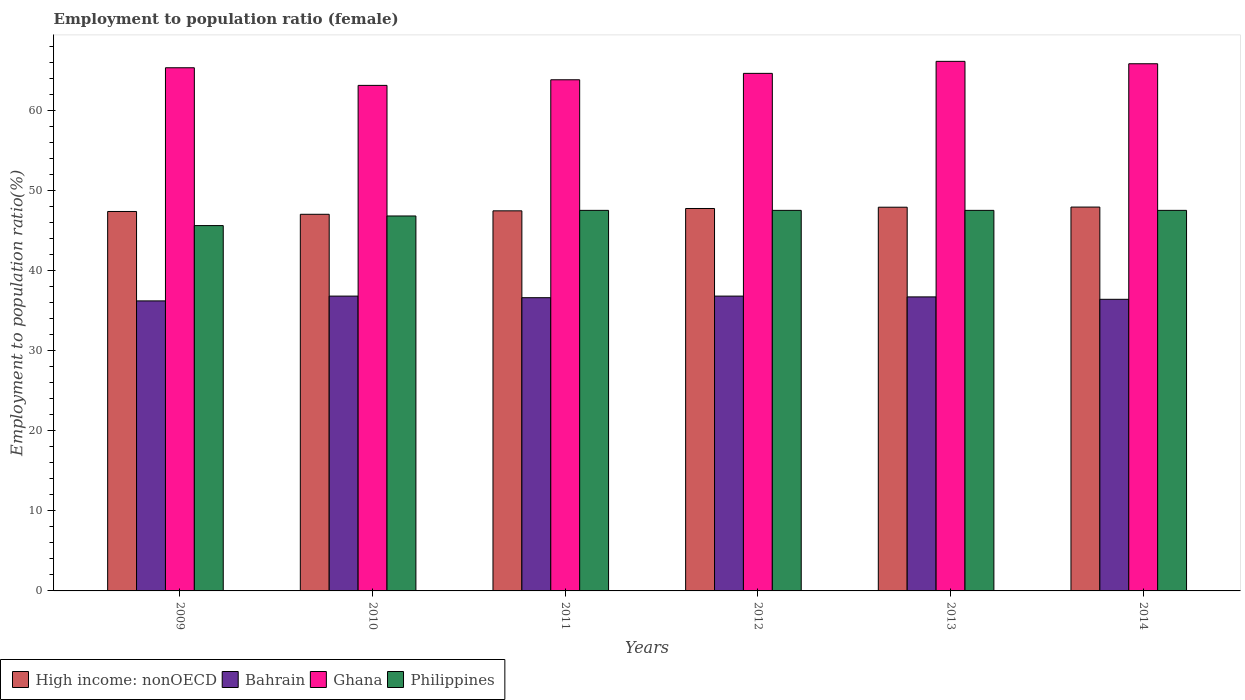Are the number of bars per tick equal to the number of legend labels?
Give a very brief answer. Yes. Are the number of bars on each tick of the X-axis equal?
Make the answer very short. Yes. How many bars are there on the 2nd tick from the right?
Keep it short and to the point. 4. What is the label of the 4th group of bars from the left?
Your response must be concise. 2012. In how many cases, is the number of bars for a given year not equal to the number of legend labels?
Ensure brevity in your answer.  0. What is the employment to population ratio in Bahrain in 2011?
Offer a terse response. 36.6. Across all years, what is the maximum employment to population ratio in Philippines?
Provide a succinct answer. 47.5. Across all years, what is the minimum employment to population ratio in Ghana?
Your response must be concise. 63.1. In which year was the employment to population ratio in Ghana minimum?
Keep it short and to the point. 2010. What is the total employment to population ratio in High income: nonOECD in the graph?
Give a very brief answer. 285.36. What is the difference between the employment to population ratio in Bahrain in 2010 and that in 2014?
Provide a succinct answer. 0.4. What is the difference between the employment to population ratio in Ghana in 2010 and the employment to population ratio in Philippines in 2014?
Ensure brevity in your answer.  15.6. What is the average employment to population ratio in High income: nonOECD per year?
Your answer should be very brief. 47.56. In the year 2009, what is the difference between the employment to population ratio in High income: nonOECD and employment to population ratio in Philippines?
Your response must be concise. 1.76. In how many years, is the employment to population ratio in Bahrain greater than 12 %?
Provide a short and direct response. 6. What is the ratio of the employment to population ratio in Philippines in 2011 to that in 2014?
Provide a succinct answer. 1. Is the difference between the employment to population ratio in High income: nonOECD in 2010 and 2012 greater than the difference between the employment to population ratio in Philippines in 2010 and 2012?
Your answer should be compact. No. What is the difference between the highest and the lowest employment to population ratio in Ghana?
Your answer should be very brief. 3. In how many years, is the employment to population ratio in Philippines greater than the average employment to population ratio in Philippines taken over all years?
Provide a short and direct response. 4. Is the sum of the employment to population ratio in Ghana in 2010 and 2011 greater than the maximum employment to population ratio in Philippines across all years?
Offer a terse response. Yes. Is it the case that in every year, the sum of the employment to population ratio in Philippines and employment to population ratio in High income: nonOECD is greater than the employment to population ratio in Bahrain?
Provide a short and direct response. Yes. How many bars are there?
Offer a very short reply. 24. How many years are there in the graph?
Make the answer very short. 6. Does the graph contain any zero values?
Your answer should be very brief. No. Does the graph contain grids?
Your answer should be very brief. No. Where does the legend appear in the graph?
Make the answer very short. Bottom left. What is the title of the graph?
Your answer should be compact. Employment to population ratio (female). What is the Employment to population ratio(%) of High income: nonOECD in 2009?
Ensure brevity in your answer.  47.36. What is the Employment to population ratio(%) in Bahrain in 2009?
Make the answer very short. 36.2. What is the Employment to population ratio(%) of Ghana in 2009?
Ensure brevity in your answer.  65.3. What is the Employment to population ratio(%) in Philippines in 2009?
Your answer should be very brief. 45.6. What is the Employment to population ratio(%) of High income: nonOECD in 2010?
Make the answer very short. 47.01. What is the Employment to population ratio(%) in Bahrain in 2010?
Offer a terse response. 36.8. What is the Employment to population ratio(%) in Ghana in 2010?
Provide a short and direct response. 63.1. What is the Employment to population ratio(%) in Philippines in 2010?
Offer a terse response. 46.8. What is the Employment to population ratio(%) in High income: nonOECD in 2011?
Ensure brevity in your answer.  47.44. What is the Employment to population ratio(%) of Bahrain in 2011?
Provide a short and direct response. 36.6. What is the Employment to population ratio(%) in Ghana in 2011?
Your response must be concise. 63.8. What is the Employment to population ratio(%) in Philippines in 2011?
Offer a terse response. 47.5. What is the Employment to population ratio(%) of High income: nonOECD in 2012?
Make the answer very short. 47.73. What is the Employment to population ratio(%) in Bahrain in 2012?
Offer a very short reply. 36.8. What is the Employment to population ratio(%) of Ghana in 2012?
Provide a short and direct response. 64.6. What is the Employment to population ratio(%) of Philippines in 2012?
Your answer should be very brief. 47.5. What is the Employment to population ratio(%) of High income: nonOECD in 2013?
Keep it short and to the point. 47.89. What is the Employment to population ratio(%) of Bahrain in 2013?
Your answer should be compact. 36.7. What is the Employment to population ratio(%) in Ghana in 2013?
Provide a short and direct response. 66.1. What is the Employment to population ratio(%) of Philippines in 2013?
Offer a terse response. 47.5. What is the Employment to population ratio(%) of High income: nonOECD in 2014?
Offer a very short reply. 47.91. What is the Employment to population ratio(%) of Bahrain in 2014?
Offer a terse response. 36.4. What is the Employment to population ratio(%) in Ghana in 2014?
Your answer should be very brief. 65.8. What is the Employment to population ratio(%) in Philippines in 2014?
Your answer should be compact. 47.5. Across all years, what is the maximum Employment to population ratio(%) of High income: nonOECD?
Offer a terse response. 47.91. Across all years, what is the maximum Employment to population ratio(%) of Bahrain?
Offer a very short reply. 36.8. Across all years, what is the maximum Employment to population ratio(%) in Ghana?
Give a very brief answer. 66.1. Across all years, what is the maximum Employment to population ratio(%) of Philippines?
Make the answer very short. 47.5. Across all years, what is the minimum Employment to population ratio(%) of High income: nonOECD?
Your response must be concise. 47.01. Across all years, what is the minimum Employment to population ratio(%) of Bahrain?
Your answer should be compact. 36.2. Across all years, what is the minimum Employment to population ratio(%) of Ghana?
Ensure brevity in your answer.  63.1. Across all years, what is the minimum Employment to population ratio(%) in Philippines?
Your answer should be very brief. 45.6. What is the total Employment to population ratio(%) of High income: nonOECD in the graph?
Your response must be concise. 285.36. What is the total Employment to population ratio(%) in Bahrain in the graph?
Your response must be concise. 219.5. What is the total Employment to population ratio(%) of Ghana in the graph?
Provide a short and direct response. 388.7. What is the total Employment to population ratio(%) in Philippines in the graph?
Offer a terse response. 282.4. What is the difference between the Employment to population ratio(%) in High income: nonOECD in 2009 and that in 2010?
Your answer should be very brief. 0.35. What is the difference between the Employment to population ratio(%) in Bahrain in 2009 and that in 2010?
Your response must be concise. -0.6. What is the difference between the Employment to population ratio(%) of Ghana in 2009 and that in 2010?
Your answer should be very brief. 2.2. What is the difference between the Employment to population ratio(%) in Philippines in 2009 and that in 2010?
Ensure brevity in your answer.  -1.2. What is the difference between the Employment to population ratio(%) of High income: nonOECD in 2009 and that in 2011?
Offer a very short reply. -0.08. What is the difference between the Employment to population ratio(%) of High income: nonOECD in 2009 and that in 2012?
Your response must be concise. -0.37. What is the difference between the Employment to population ratio(%) of Philippines in 2009 and that in 2012?
Your response must be concise. -1.9. What is the difference between the Employment to population ratio(%) of High income: nonOECD in 2009 and that in 2013?
Provide a short and direct response. -0.53. What is the difference between the Employment to population ratio(%) of Bahrain in 2009 and that in 2013?
Offer a terse response. -0.5. What is the difference between the Employment to population ratio(%) in Ghana in 2009 and that in 2013?
Give a very brief answer. -0.8. What is the difference between the Employment to population ratio(%) in High income: nonOECD in 2009 and that in 2014?
Make the answer very short. -0.55. What is the difference between the Employment to population ratio(%) in Bahrain in 2009 and that in 2014?
Give a very brief answer. -0.2. What is the difference between the Employment to population ratio(%) in Philippines in 2009 and that in 2014?
Give a very brief answer. -1.9. What is the difference between the Employment to population ratio(%) of High income: nonOECD in 2010 and that in 2011?
Provide a short and direct response. -0.43. What is the difference between the Employment to population ratio(%) of Bahrain in 2010 and that in 2011?
Give a very brief answer. 0.2. What is the difference between the Employment to population ratio(%) in Ghana in 2010 and that in 2011?
Provide a succinct answer. -0.7. What is the difference between the Employment to population ratio(%) of Philippines in 2010 and that in 2011?
Your response must be concise. -0.7. What is the difference between the Employment to population ratio(%) of High income: nonOECD in 2010 and that in 2012?
Offer a very short reply. -0.72. What is the difference between the Employment to population ratio(%) in Ghana in 2010 and that in 2012?
Make the answer very short. -1.5. What is the difference between the Employment to population ratio(%) in Philippines in 2010 and that in 2012?
Make the answer very short. -0.7. What is the difference between the Employment to population ratio(%) of High income: nonOECD in 2010 and that in 2013?
Offer a very short reply. -0.88. What is the difference between the Employment to population ratio(%) in Ghana in 2010 and that in 2013?
Provide a short and direct response. -3. What is the difference between the Employment to population ratio(%) of High income: nonOECD in 2011 and that in 2012?
Your answer should be compact. -0.29. What is the difference between the Employment to population ratio(%) in Bahrain in 2011 and that in 2012?
Offer a very short reply. -0.2. What is the difference between the Employment to population ratio(%) of Philippines in 2011 and that in 2012?
Offer a very short reply. 0. What is the difference between the Employment to population ratio(%) in High income: nonOECD in 2011 and that in 2013?
Your answer should be compact. -0.45. What is the difference between the Employment to population ratio(%) in High income: nonOECD in 2011 and that in 2014?
Give a very brief answer. -0.47. What is the difference between the Employment to population ratio(%) in Bahrain in 2011 and that in 2014?
Your response must be concise. 0.2. What is the difference between the Employment to population ratio(%) of High income: nonOECD in 2012 and that in 2013?
Make the answer very short. -0.16. What is the difference between the Employment to population ratio(%) of Ghana in 2012 and that in 2013?
Your answer should be very brief. -1.5. What is the difference between the Employment to population ratio(%) in Philippines in 2012 and that in 2013?
Your answer should be compact. 0. What is the difference between the Employment to population ratio(%) of High income: nonOECD in 2012 and that in 2014?
Your answer should be very brief. -0.18. What is the difference between the Employment to population ratio(%) in Bahrain in 2012 and that in 2014?
Your response must be concise. 0.4. What is the difference between the Employment to population ratio(%) in High income: nonOECD in 2013 and that in 2014?
Provide a succinct answer. -0.02. What is the difference between the Employment to population ratio(%) of Ghana in 2013 and that in 2014?
Offer a very short reply. 0.3. What is the difference between the Employment to population ratio(%) of High income: nonOECD in 2009 and the Employment to population ratio(%) of Bahrain in 2010?
Provide a short and direct response. 10.56. What is the difference between the Employment to population ratio(%) in High income: nonOECD in 2009 and the Employment to population ratio(%) in Ghana in 2010?
Offer a very short reply. -15.74. What is the difference between the Employment to population ratio(%) of High income: nonOECD in 2009 and the Employment to population ratio(%) of Philippines in 2010?
Provide a succinct answer. 0.56. What is the difference between the Employment to population ratio(%) in Bahrain in 2009 and the Employment to population ratio(%) in Ghana in 2010?
Provide a succinct answer. -26.9. What is the difference between the Employment to population ratio(%) of High income: nonOECD in 2009 and the Employment to population ratio(%) of Bahrain in 2011?
Offer a terse response. 10.76. What is the difference between the Employment to population ratio(%) of High income: nonOECD in 2009 and the Employment to population ratio(%) of Ghana in 2011?
Offer a very short reply. -16.44. What is the difference between the Employment to population ratio(%) in High income: nonOECD in 2009 and the Employment to population ratio(%) in Philippines in 2011?
Offer a very short reply. -0.14. What is the difference between the Employment to population ratio(%) of Bahrain in 2009 and the Employment to population ratio(%) of Ghana in 2011?
Give a very brief answer. -27.6. What is the difference between the Employment to population ratio(%) of Bahrain in 2009 and the Employment to population ratio(%) of Philippines in 2011?
Offer a terse response. -11.3. What is the difference between the Employment to population ratio(%) in Ghana in 2009 and the Employment to population ratio(%) in Philippines in 2011?
Provide a short and direct response. 17.8. What is the difference between the Employment to population ratio(%) of High income: nonOECD in 2009 and the Employment to population ratio(%) of Bahrain in 2012?
Offer a terse response. 10.56. What is the difference between the Employment to population ratio(%) of High income: nonOECD in 2009 and the Employment to population ratio(%) of Ghana in 2012?
Ensure brevity in your answer.  -17.24. What is the difference between the Employment to population ratio(%) of High income: nonOECD in 2009 and the Employment to population ratio(%) of Philippines in 2012?
Offer a terse response. -0.14. What is the difference between the Employment to population ratio(%) of Bahrain in 2009 and the Employment to population ratio(%) of Ghana in 2012?
Keep it short and to the point. -28.4. What is the difference between the Employment to population ratio(%) of Ghana in 2009 and the Employment to population ratio(%) of Philippines in 2012?
Your response must be concise. 17.8. What is the difference between the Employment to population ratio(%) in High income: nonOECD in 2009 and the Employment to population ratio(%) in Bahrain in 2013?
Offer a very short reply. 10.66. What is the difference between the Employment to population ratio(%) of High income: nonOECD in 2009 and the Employment to population ratio(%) of Ghana in 2013?
Your response must be concise. -18.74. What is the difference between the Employment to population ratio(%) in High income: nonOECD in 2009 and the Employment to population ratio(%) in Philippines in 2013?
Your answer should be very brief. -0.14. What is the difference between the Employment to population ratio(%) of Bahrain in 2009 and the Employment to population ratio(%) of Ghana in 2013?
Offer a very short reply. -29.9. What is the difference between the Employment to population ratio(%) in Ghana in 2009 and the Employment to population ratio(%) in Philippines in 2013?
Ensure brevity in your answer.  17.8. What is the difference between the Employment to population ratio(%) of High income: nonOECD in 2009 and the Employment to population ratio(%) of Bahrain in 2014?
Provide a short and direct response. 10.96. What is the difference between the Employment to population ratio(%) in High income: nonOECD in 2009 and the Employment to population ratio(%) in Ghana in 2014?
Ensure brevity in your answer.  -18.44. What is the difference between the Employment to population ratio(%) in High income: nonOECD in 2009 and the Employment to population ratio(%) in Philippines in 2014?
Make the answer very short. -0.14. What is the difference between the Employment to population ratio(%) of Bahrain in 2009 and the Employment to population ratio(%) of Ghana in 2014?
Ensure brevity in your answer.  -29.6. What is the difference between the Employment to population ratio(%) of Bahrain in 2009 and the Employment to population ratio(%) of Philippines in 2014?
Give a very brief answer. -11.3. What is the difference between the Employment to population ratio(%) of High income: nonOECD in 2010 and the Employment to population ratio(%) of Bahrain in 2011?
Ensure brevity in your answer.  10.41. What is the difference between the Employment to population ratio(%) of High income: nonOECD in 2010 and the Employment to population ratio(%) of Ghana in 2011?
Your answer should be very brief. -16.79. What is the difference between the Employment to population ratio(%) in High income: nonOECD in 2010 and the Employment to population ratio(%) in Philippines in 2011?
Ensure brevity in your answer.  -0.49. What is the difference between the Employment to population ratio(%) in Bahrain in 2010 and the Employment to population ratio(%) in Ghana in 2011?
Your response must be concise. -27. What is the difference between the Employment to population ratio(%) of Bahrain in 2010 and the Employment to population ratio(%) of Philippines in 2011?
Your answer should be compact. -10.7. What is the difference between the Employment to population ratio(%) of High income: nonOECD in 2010 and the Employment to population ratio(%) of Bahrain in 2012?
Ensure brevity in your answer.  10.21. What is the difference between the Employment to population ratio(%) in High income: nonOECD in 2010 and the Employment to population ratio(%) in Ghana in 2012?
Your response must be concise. -17.59. What is the difference between the Employment to population ratio(%) in High income: nonOECD in 2010 and the Employment to population ratio(%) in Philippines in 2012?
Provide a short and direct response. -0.49. What is the difference between the Employment to population ratio(%) of Bahrain in 2010 and the Employment to population ratio(%) of Ghana in 2012?
Keep it short and to the point. -27.8. What is the difference between the Employment to population ratio(%) of Bahrain in 2010 and the Employment to population ratio(%) of Philippines in 2012?
Offer a terse response. -10.7. What is the difference between the Employment to population ratio(%) in High income: nonOECD in 2010 and the Employment to population ratio(%) in Bahrain in 2013?
Provide a short and direct response. 10.31. What is the difference between the Employment to population ratio(%) in High income: nonOECD in 2010 and the Employment to population ratio(%) in Ghana in 2013?
Your response must be concise. -19.09. What is the difference between the Employment to population ratio(%) of High income: nonOECD in 2010 and the Employment to population ratio(%) of Philippines in 2013?
Ensure brevity in your answer.  -0.49. What is the difference between the Employment to population ratio(%) in Bahrain in 2010 and the Employment to population ratio(%) in Ghana in 2013?
Keep it short and to the point. -29.3. What is the difference between the Employment to population ratio(%) in High income: nonOECD in 2010 and the Employment to population ratio(%) in Bahrain in 2014?
Offer a terse response. 10.61. What is the difference between the Employment to population ratio(%) of High income: nonOECD in 2010 and the Employment to population ratio(%) of Ghana in 2014?
Keep it short and to the point. -18.79. What is the difference between the Employment to population ratio(%) in High income: nonOECD in 2010 and the Employment to population ratio(%) in Philippines in 2014?
Offer a very short reply. -0.49. What is the difference between the Employment to population ratio(%) in Bahrain in 2010 and the Employment to population ratio(%) in Ghana in 2014?
Offer a terse response. -29. What is the difference between the Employment to population ratio(%) in Bahrain in 2010 and the Employment to population ratio(%) in Philippines in 2014?
Make the answer very short. -10.7. What is the difference between the Employment to population ratio(%) in Ghana in 2010 and the Employment to population ratio(%) in Philippines in 2014?
Ensure brevity in your answer.  15.6. What is the difference between the Employment to population ratio(%) in High income: nonOECD in 2011 and the Employment to population ratio(%) in Bahrain in 2012?
Keep it short and to the point. 10.64. What is the difference between the Employment to population ratio(%) in High income: nonOECD in 2011 and the Employment to population ratio(%) in Ghana in 2012?
Ensure brevity in your answer.  -17.16. What is the difference between the Employment to population ratio(%) of High income: nonOECD in 2011 and the Employment to population ratio(%) of Philippines in 2012?
Provide a succinct answer. -0.06. What is the difference between the Employment to population ratio(%) of Bahrain in 2011 and the Employment to population ratio(%) of Ghana in 2012?
Your answer should be compact. -28. What is the difference between the Employment to population ratio(%) in Ghana in 2011 and the Employment to population ratio(%) in Philippines in 2012?
Offer a very short reply. 16.3. What is the difference between the Employment to population ratio(%) in High income: nonOECD in 2011 and the Employment to population ratio(%) in Bahrain in 2013?
Provide a short and direct response. 10.74. What is the difference between the Employment to population ratio(%) in High income: nonOECD in 2011 and the Employment to population ratio(%) in Ghana in 2013?
Give a very brief answer. -18.66. What is the difference between the Employment to population ratio(%) in High income: nonOECD in 2011 and the Employment to population ratio(%) in Philippines in 2013?
Provide a short and direct response. -0.06. What is the difference between the Employment to population ratio(%) of Bahrain in 2011 and the Employment to population ratio(%) of Ghana in 2013?
Provide a succinct answer. -29.5. What is the difference between the Employment to population ratio(%) of Bahrain in 2011 and the Employment to population ratio(%) of Philippines in 2013?
Keep it short and to the point. -10.9. What is the difference between the Employment to population ratio(%) of High income: nonOECD in 2011 and the Employment to population ratio(%) of Bahrain in 2014?
Your response must be concise. 11.04. What is the difference between the Employment to population ratio(%) in High income: nonOECD in 2011 and the Employment to population ratio(%) in Ghana in 2014?
Provide a short and direct response. -18.36. What is the difference between the Employment to population ratio(%) of High income: nonOECD in 2011 and the Employment to population ratio(%) of Philippines in 2014?
Give a very brief answer. -0.06. What is the difference between the Employment to population ratio(%) of Bahrain in 2011 and the Employment to population ratio(%) of Ghana in 2014?
Offer a terse response. -29.2. What is the difference between the Employment to population ratio(%) in Bahrain in 2011 and the Employment to population ratio(%) in Philippines in 2014?
Keep it short and to the point. -10.9. What is the difference between the Employment to population ratio(%) of High income: nonOECD in 2012 and the Employment to population ratio(%) of Bahrain in 2013?
Provide a short and direct response. 11.03. What is the difference between the Employment to population ratio(%) in High income: nonOECD in 2012 and the Employment to population ratio(%) in Ghana in 2013?
Your response must be concise. -18.37. What is the difference between the Employment to population ratio(%) in High income: nonOECD in 2012 and the Employment to population ratio(%) in Philippines in 2013?
Keep it short and to the point. 0.23. What is the difference between the Employment to population ratio(%) in Bahrain in 2012 and the Employment to population ratio(%) in Ghana in 2013?
Provide a short and direct response. -29.3. What is the difference between the Employment to population ratio(%) in Bahrain in 2012 and the Employment to population ratio(%) in Philippines in 2013?
Provide a short and direct response. -10.7. What is the difference between the Employment to population ratio(%) of High income: nonOECD in 2012 and the Employment to population ratio(%) of Bahrain in 2014?
Keep it short and to the point. 11.33. What is the difference between the Employment to population ratio(%) in High income: nonOECD in 2012 and the Employment to population ratio(%) in Ghana in 2014?
Make the answer very short. -18.07. What is the difference between the Employment to population ratio(%) in High income: nonOECD in 2012 and the Employment to population ratio(%) in Philippines in 2014?
Offer a very short reply. 0.23. What is the difference between the Employment to population ratio(%) of Bahrain in 2012 and the Employment to population ratio(%) of Philippines in 2014?
Your response must be concise. -10.7. What is the difference between the Employment to population ratio(%) of Ghana in 2012 and the Employment to population ratio(%) of Philippines in 2014?
Provide a short and direct response. 17.1. What is the difference between the Employment to population ratio(%) in High income: nonOECD in 2013 and the Employment to population ratio(%) in Bahrain in 2014?
Keep it short and to the point. 11.49. What is the difference between the Employment to population ratio(%) of High income: nonOECD in 2013 and the Employment to population ratio(%) of Ghana in 2014?
Offer a terse response. -17.91. What is the difference between the Employment to population ratio(%) of High income: nonOECD in 2013 and the Employment to population ratio(%) of Philippines in 2014?
Offer a terse response. 0.39. What is the difference between the Employment to population ratio(%) in Bahrain in 2013 and the Employment to population ratio(%) in Ghana in 2014?
Provide a short and direct response. -29.1. What is the average Employment to population ratio(%) in High income: nonOECD per year?
Keep it short and to the point. 47.56. What is the average Employment to population ratio(%) of Bahrain per year?
Make the answer very short. 36.58. What is the average Employment to population ratio(%) in Ghana per year?
Make the answer very short. 64.78. What is the average Employment to population ratio(%) of Philippines per year?
Keep it short and to the point. 47.07. In the year 2009, what is the difference between the Employment to population ratio(%) of High income: nonOECD and Employment to population ratio(%) of Bahrain?
Give a very brief answer. 11.16. In the year 2009, what is the difference between the Employment to population ratio(%) in High income: nonOECD and Employment to population ratio(%) in Ghana?
Provide a succinct answer. -17.94. In the year 2009, what is the difference between the Employment to population ratio(%) in High income: nonOECD and Employment to population ratio(%) in Philippines?
Your answer should be very brief. 1.76. In the year 2009, what is the difference between the Employment to population ratio(%) in Bahrain and Employment to population ratio(%) in Ghana?
Ensure brevity in your answer.  -29.1. In the year 2009, what is the difference between the Employment to population ratio(%) of Bahrain and Employment to population ratio(%) of Philippines?
Keep it short and to the point. -9.4. In the year 2010, what is the difference between the Employment to population ratio(%) of High income: nonOECD and Employment to population ratio(%) of Bahrain?
Your answer should be compact. 10.21. In the year 2010, what is the difference between the Employment to population ratio(%) in High income: nonOECD and Employment to population ratio(%) in Ghana?
Your answer should be compact. -16.09. In the year 2010, what is the difference between the Employment to population ratio(%) of High income: nonOECD and Employment to population ratio(%) of Philippines?
Your answer should be very brief. 0.21. In the year 2010, what is the difference between the Employment to population ratio(%) of Bahrain and Employment to population ratio(%) of Ghana?
Your answer should be very brief. -26.3. In the year 2010, what is the difference between the Employment to population ratio(%) in Bahrain and Employment to population ratio(%) in Philippines?
Your response must be concise. -10. In the year 2010, what is the difference between the Employment to population ratio(%) in Ghana and Employment to population ratio(%) in Philippines?
Your answer should be compact. 16.3. In the year 2011, what is the difference between the Employment to population ratio(%) in High income: nonOECD and Employment to population ratio(%) in Bahrain?
Your answer should be compact. 10.84. In the year 2011, what is the difference between the Employment to population ratio(%) in High income: nonOECD and Employment to population ratio(%) in Ghana?
Offer a very short reply. -16.36. In the year 2011, what is the difference between the Employment to population ratio(%) in High income: nonOECD and Employment to population ratio(%) in Philippines?
Your answer should be compact. -0.06. In the year 2011, what is the difference between the Employment to population ratio(%) of Bahrain and Employment to population ratio(%) of Ghana?
Ensure brevity in your answer.  -27.2. In the year 2011, what is the difference between the Employment to population ratio(%) of Bahrain and Employment to population ratio(%) of Philippines?
Give a very brief answer. -10.9. In the year 2012, what is the difference between the Employment to population ratio(%) in High income: nonOECD and Employment to population ratio(%) in Bahrain?
Give a very brief answer. 10.93. In the year 2012, what is the difference between the Employment to population ratio(%) in High income: nonOECD and Employment to population ratio(%) in Ghana?
Make the answer very short. -16.87. In the year 2012, what is the difference between the Employment to population ratio(%) of High income: nonOECD and Employment to population ratio(%) of Philippines?
Keep it short and to the point. 0.23. In the year 2012, what is the difference between the Employment to population ratio(%) in Bahrain and Employment to population ratio(%) in Ghana?
Keep it short and to the point. -27.8. In the year 2012, what is the difference between the Employment to population ratio(%) of Ghana and Employment to population ratio(%) of Philippines?
Offer a terse response. 17.1. In the year 2013, what is the difference between the Employment to population ratio(%) in High income: nonOECD and Employment to population ratio(%) in Bahrain?
Offer a very short reply. 11.19. In the year 2013, what is the difference between the Employment to population ratio(%) in High income: nonOECD and Employment to population ratio(%) in Ghana?
Offer a terse response. -18.21. In the year 2013, what is the difference between the Employment to population ratio(%) of High income: nonOECD and Employment to population ratio(%) of Philippines?
Ensure brevity in your answer.  0.39. In the year 2013, what is the difference between the Employment to population ratio(%) in Bahrain and Employment to population ratio(%) in Ghana?
Offer a terse response. -29.4. In the year 2014, what is the difference between the Employment to population ratio(%) in High income: nonOECD and Employment to population ratio(%) in Bahrain?
Provide a succinct answer. 11.51. In the year 2014, what is the difference between the Employment to population ratio(%) of High income: nonOECD and Employment to population ratio(%) of Ghana?
Provide a short and direct response. -17.89. In the year 2014, what is the difference between the Employment to population ratio(%) in High income: nonOECD and Employment to population ratio(%) in Philippines?
Ensure brevity in your answer.  0.41. In the year 2014, what is the difference between the Employment to population ratio(%) of Bahrain and Employment to population ratio(%) of Ghana?
Provide a succinct answer. -29.4. In the year 2014, what is the difference between the Employment to population ratio(%) in Bahrain and Employment to population ratio(%) in Philippines?
Give a very brief answer. -11.1. In the year 2014, what is the difference between the Employment to population ratio(%) in Ghana and Employment to population ratio(%) in Philippines?
Keep it short and to the point. 18.3. What is the ratio of the Employment to population ratio(%) in High income: nonOECD in 2009 to that in 2010?
Keep it short and to the point. 1.01. What is the ratio of the Employment to population ratio(%) of Bahrain in 2009 to that in 2010?
Your answer should be compact. 0.98. What is the ratio of the Employment to population ratio(%) in Ghana in 2009 to that in 2010?
Keep it short and to the point. 1.03. What is the ratio of the Employment to population ratio(%) in Philippines in 2009 to that in 2010?
Your answer should be compact. 0.97. What is the ratio of the Employment to population ratio(%) of High income: nonOECD in 2009 to that in 2011?
Your response must be concise. 1. What is the ratio of the Employment to population ratio(%) of Ghana in 2009 to that in 2011?
Your response must be concise. 1.02. What is the ratio of the Employment to population ratio(%) of Bahrain in 2009 to that in 2012?
Provide a short and direct response. 0.98. What is the ratio of the Employment to population ratio(%) in Ghana in 2009 to that in 2012?
Offer a very short reply. 1.01. What is the ratio of the Employment to population ratio(%) of High income: nonOECD in 2009 to that in 2013?
Offer a very short reply. 0.99. What is the ratio of the Employment to population ratio(%) in Bahrain in 2009 to that in 2013?
Your response must be concise. 0.99. What is the ratio of the Employment to population ratio(%) in Ghana in 2009 to that in 2013?
Provide a short and direct response. 0.99. What is the ratio of the Employment to population ratio(%) in High income: nonOECD in 2009 to that in 2014?
Offer a terse response. 0.99. What is the ratio of the Employment to population ratio(%) in Ghana in 2009 to that in 2014?
Ensure brevity in your answer.  0.99. What is the ratio of the Employment to population ratio(%) of Philippines in 2009 to that in 2014?
Keep it short and to the point. 0.96. What is the ratio of the Employment to population ratio(%) of High income: nonOECD in 2010 to that in 2011?
Provide a succinct answer. 0.99. What is the ratio of the Employment to population ratio(%) of Bahrain in 2010 to that in 2011?
Provide a short and direct response. 1.01. What is the ratio of the Employment to population ratio(%) of Ghana in 2010 to that in 2011?
Your answer should be compact. 0.99. What is the ratio of the Employment to population ratio(%) in Philippines in 2010 to that in 2011?
Your answer should be very brief. 0.99. What is the ratio of the Employment to population ratio(%) in High income: nonOECD in 2010 to that in 2012?
Ensure brevity in your answer.  0.98. What is the ratio of the Employment to population ratio(%) in Ghana in 2010 to that in 2012?
Offer a very short reply. 0.98. What is the ratio of the Employment to population ratio(%) of Philippines in 2010 to that in 2012?
Offer a very short reply. 0.99. What is the ratio of the Employment to population ratio(%) of High income: nonOECD in 2010 to that in 2013?
Keep it short and to the point. 0.98. What is the ratio of the Employment to population ratio(%) of Ghana in 2010 to that in 2013?
Keep it short and to the point. 0.95. What is the ratio of the Employment to population ratio(%) in High income: nonOECD in 2010 to that in 2014?
Offer a terse response. 0.98. What is the ratio of the Employment to population ratio(%) of Ghana in 2010 to that in 2014?
Offer a very short reply. 0.96. What is the ratio of the Employment to population ratio(%) of High income: nonOECD in 2011 to that in 2012?
Your response must be concise. 0.99. What is the ratio of the Employment to population ratio(%) in Ghana in 2011 to that in 2012?
Provide a succinct answer. 0.99. What is the ratio of the Employment to population ratio(%) of High income: nonOECD in 2011 to that in 2013?
Give a very brief answer. 0.99. What is the ratio of the Employment to population ratio(%) in Ghana in 2011 to that in 2013?
Provide a short and direct response. 0.97. What is the ratio of the Employment to population ratio(%) in Philippines in 2011 to that in 2013?
Your answer should be very brief. 1. What is the ratio of the Employment to population ratio(%) of High income: nonOECD in 2011 to that in 2014?
Your answer should be very brief. 0.99. What is the ratio of the Employment to population ratio(%) of Bahrain in 2011 to that in 2014?
Provide a short and direct response. 1.01. What is the ratio of the Employment to population ratio(%) in Ghana in 2011 to that in 2014?
Keep it short and to the point. 0.97. What is the ratio of the Employment to population ratio(%) in Bahrain in 2012 to that in 2013?
Keep it short and to the point. 1. What is the ratio of the Employment to population ratio(%) in Ghana in 2012 to that in 2013?
Make the answer very short. 0.98. What is the ratio of the Employment to population ratio(%) in Bahrain in 2012 to that in 2014?
Offer a terse response. 1.01. What is the ratio of the Employment to population ratio(%) of Ghana in 2012 to that in 2014?
Your answer should be compact. 0.98. What is the ratio of the Employment to population ratio(%) of High income: nonOECD in 2013 to that in 2014?
Provide a succinct answer. 1. What is the ratio of the Employment to population ratio(%) of Bahrain in 2013 to that in 2014?
Provide a succinct answer. 1.01. What is the difference between the highest and the second highest Employment to population ratio(%) of High income: nonOECD?
Your answer should be compact. 0.02. What is the difference between the highest and the lowest Employment to population ratio(%) in High income: nonOECD?
Your answer should be very brief. 0.9. What is the difference between the highest and the lowest Employment to population ratio(%) in Bahrain?
Give a very brief answer. 0.6. 